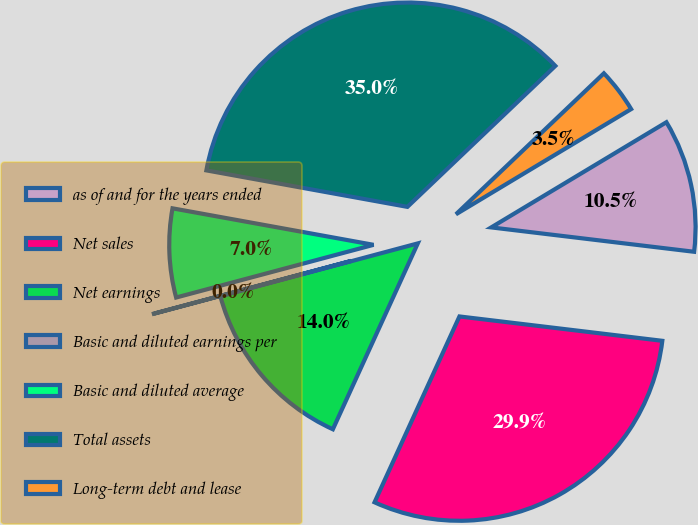Convert chart. <chart><loc_0><loc_0><loc_500><loc_500><pie_chart><fcel>as of and for the years ended<fcel>Net sales<fcel>Net earnings<fcel>Basic and diluted earnings per<fcel>Basic and diluted average<fcel>Total assets<fcel>Long-term debt and lease<nl><fcel>10.51%<fcel>29.92%<fcel>14.02%<fcel>0.01%<fcel>7.01%<fcel>35.03%<fcel>3.51%<nl></chart> 